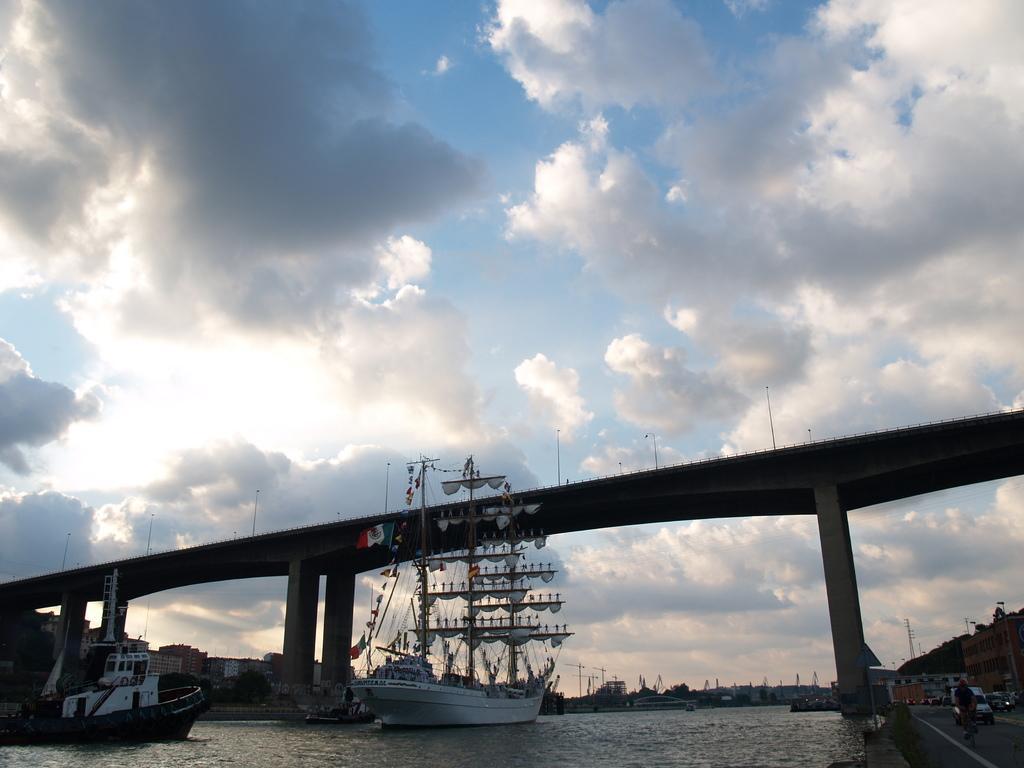How would you summarize this image in a sentence or two? In this picture we can see there are ships on the water and on the right side of the ships there are some vehicles on the road. Behind the ships there is a bridge, buildings and a sky. 